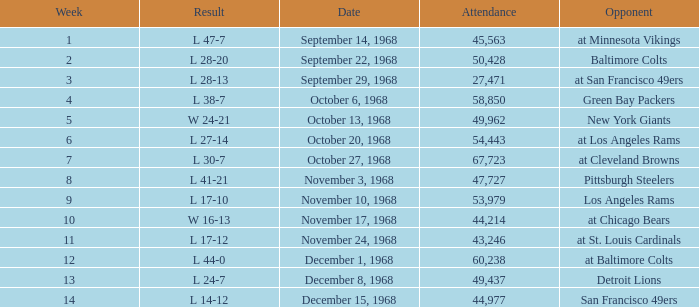Which Week has an Opponent of pittsburgh steelers, and an Attendance larger than 47,727? None. 